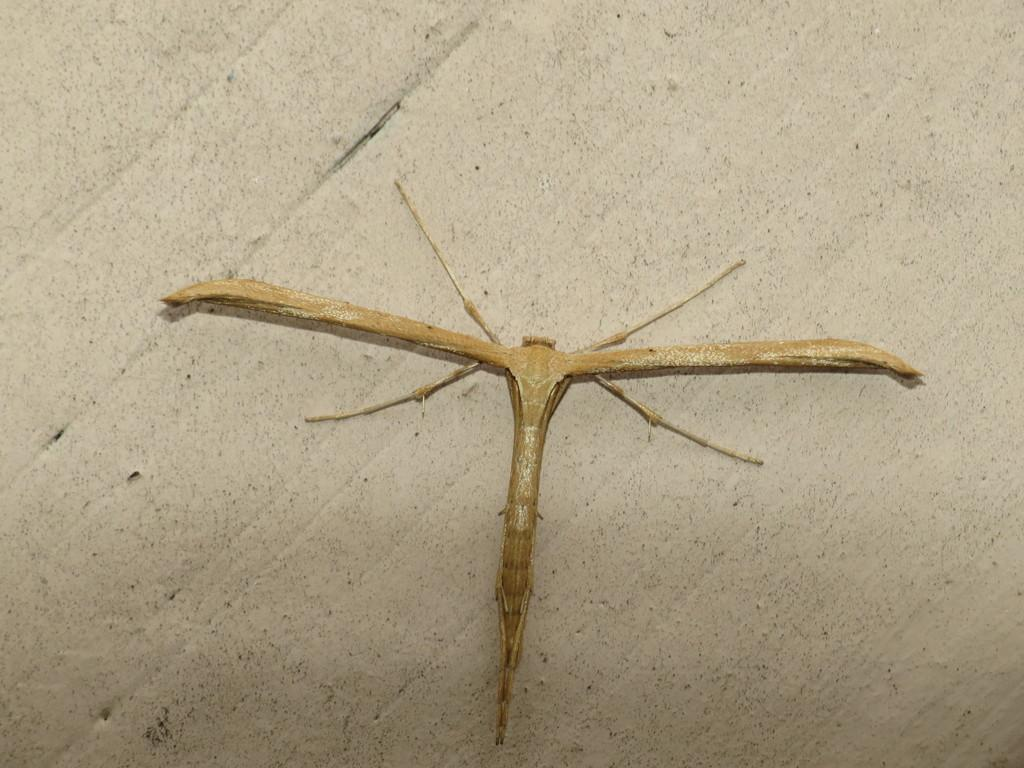What is present on the wall in the image? There is an insect on the wall in the image. What color is the background of the image? The background of the image is white. What type of apparel is the farmer wearing in the image? There is no farmer or apparel present in the image; it features an insect on a white background. What effect does the insect have on the farmer in the image? There is no farmer or interaction between the insect and a farmer in the image. 